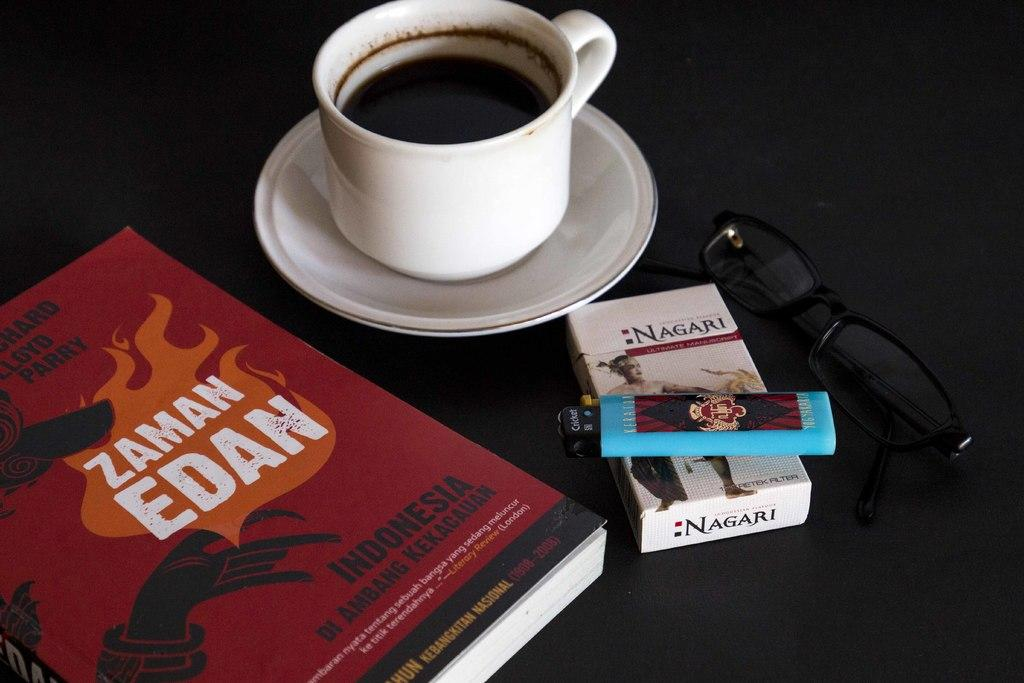<image>
Relay a brief, clear account of the picture shown. a book by Zaman Edan sits next to a cup of coffee. 